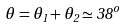<formula> <loc_0><loc_0><loc_500><loc_500>\theta = \theta _ { 1 } + \theta _ { 2 } \simeq 3 8 ^ { o }</formula> 